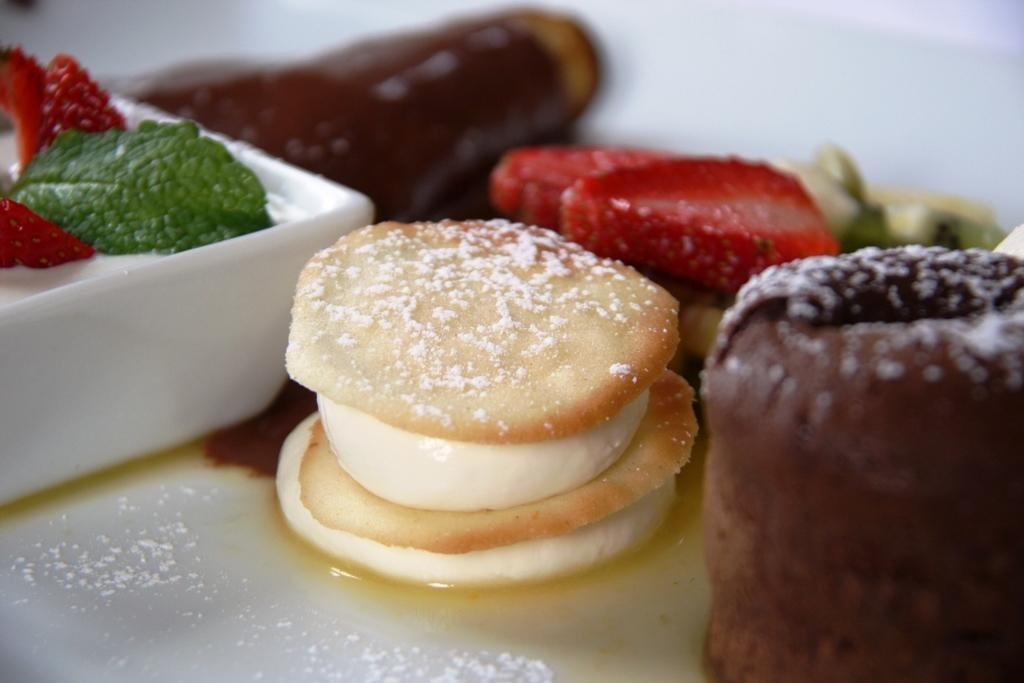What types of items can be seen in the image? There are food items in the image. What color is the bowl in the image? The bowl in the image is white. What color is the plate in the image? The plate in the image is white. What type of skirt is visible in the image? There is no skirt present in the image. 